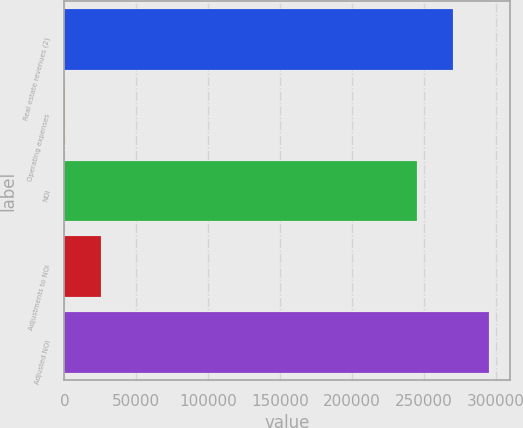<chart> <loc_0><loc_0><loc_500><loc_500><bar_chart><fcel>Real estate revenues (2)<fcel>Operating expenses<fcel>NOI<fcel>Adjustments to NOI<fcel>Adjusted NOI<nl><fcel>270286<fcel>377<fcel>245360<fcel>25302.7<fcel>295211<nl></chart> 